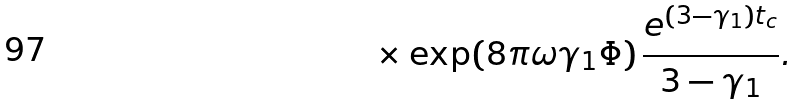<formula> <loc_0><loc_0><loc_500><loc_500>\times \exp ( 8 \pi \omega \gamma _ { 1 } \Phi ) \, \frac { e ^ { ( 3 - \gamma _ { 1 } ) t _ { c } } } { 3 - \gamma _ { 1 } } .</formula> 